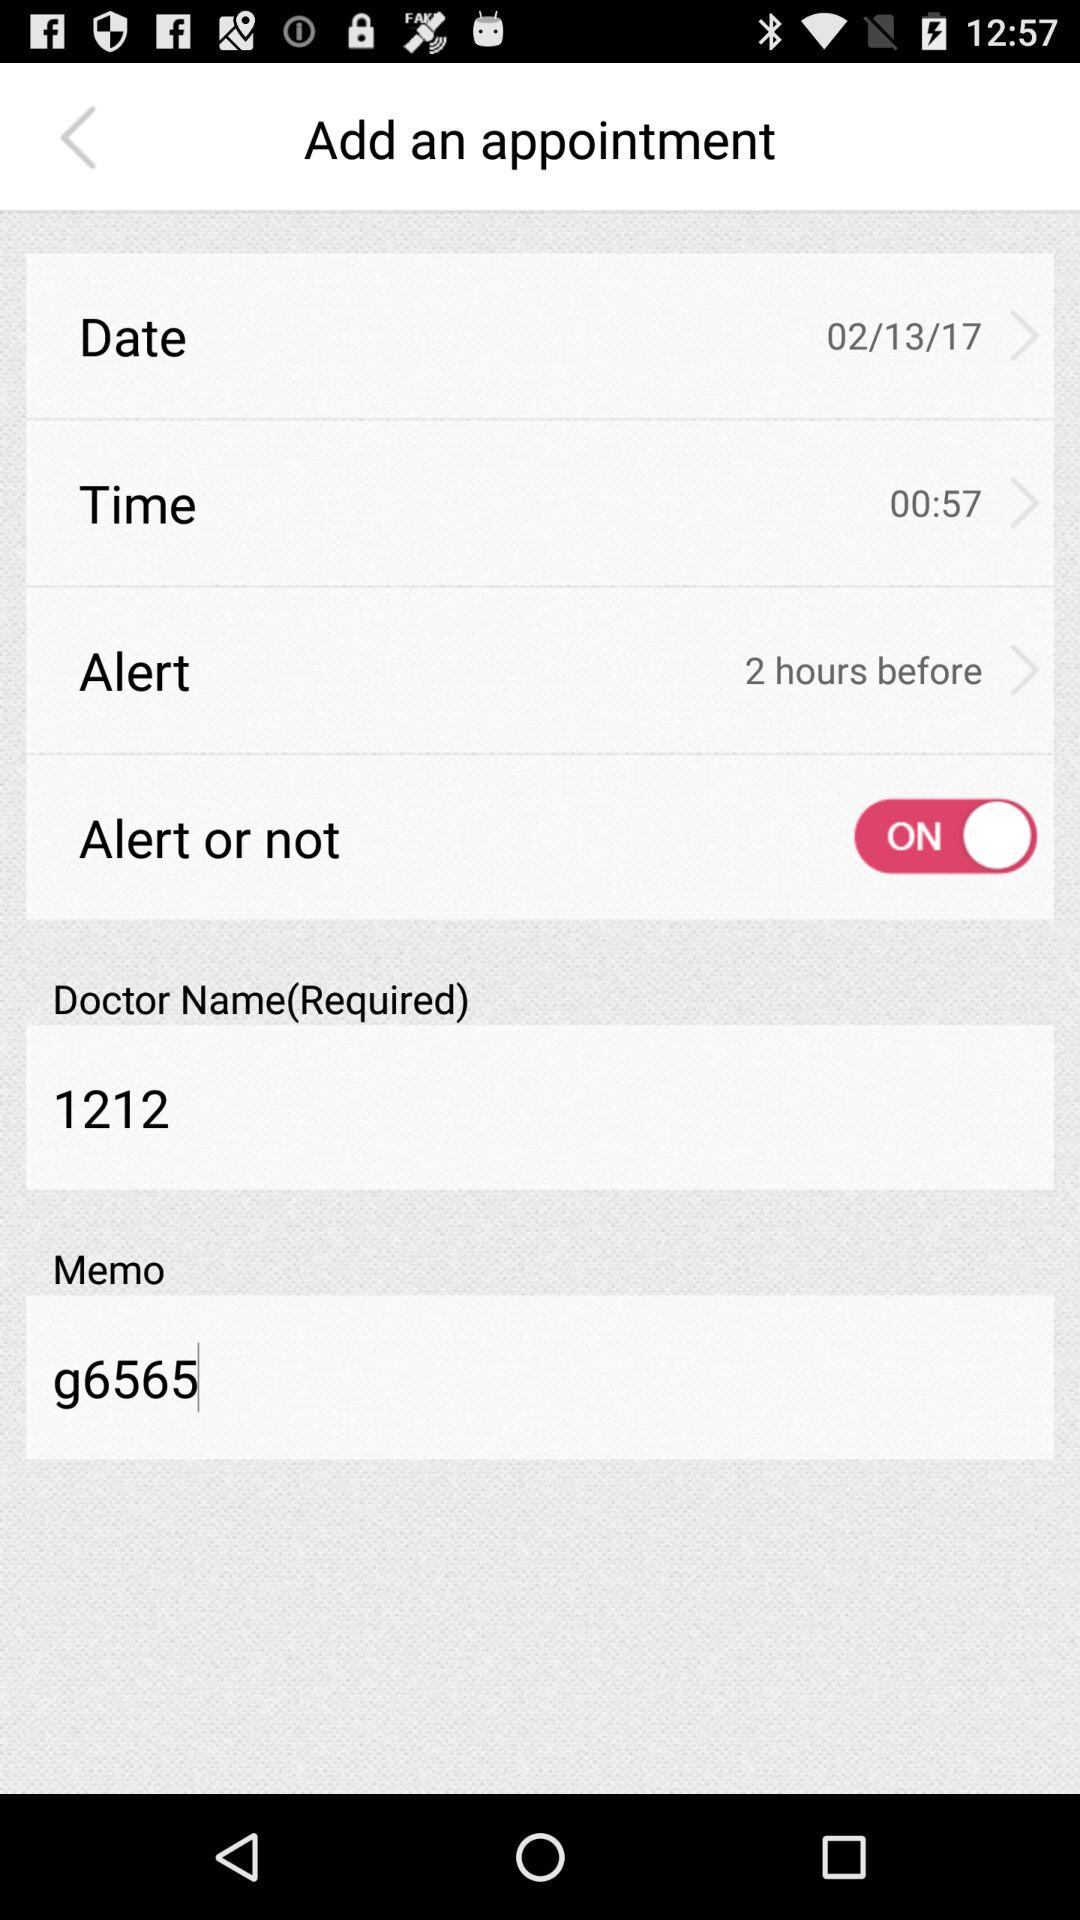What is the status of the "Alert or not"? The status is on. 